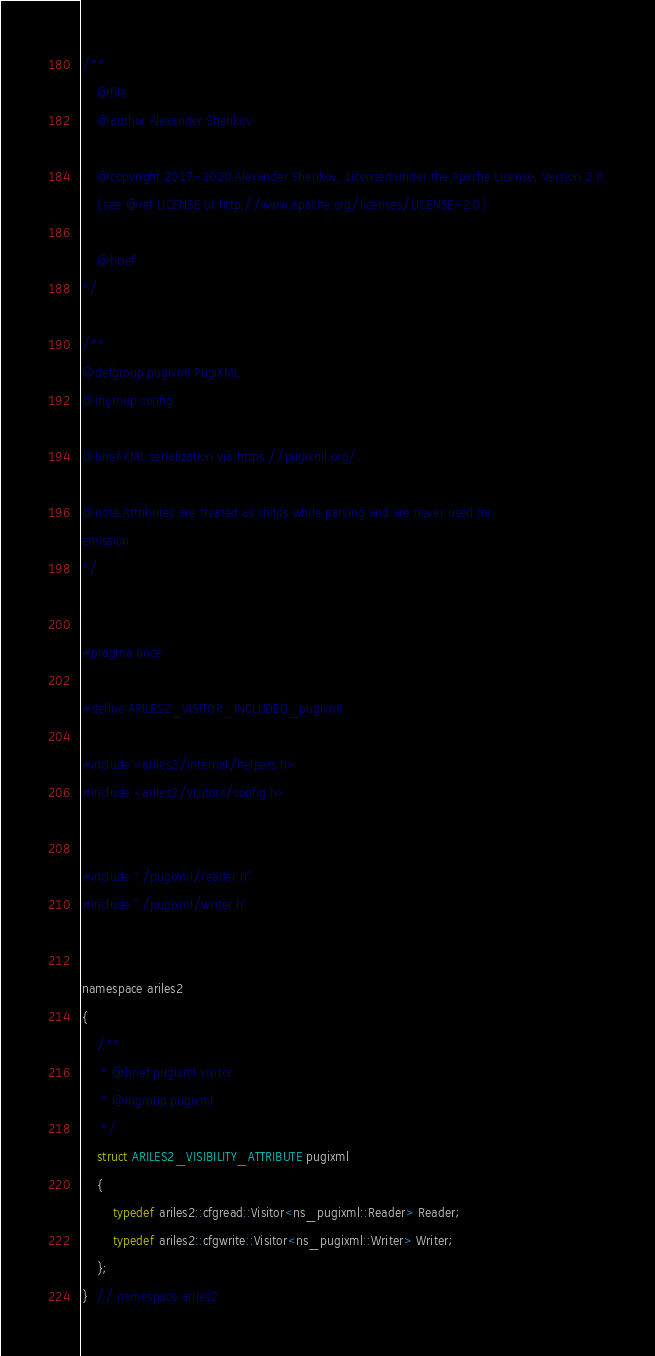<code> <loc_0><loc_0><loc_500><loc_500><_C_>/**
    @file
    @author Alexander Sherikov

    @copyright 2017-2020 Alexander Sherikov, Licensed under the Apache License, Version 2.0.
    (see @ref LICENSE or http://www.apache.org/licenses/LICENSE-2.0)

    @brief
*/

/**
@defgroup pugixml PugiXML
@ingroup config

@brief XML serialization via https://pugixml.org/.

@note Attributes are treated as childs while parsing and are never used for
emission.
*/


#pragma once

#define ARILES2_VISITOR_INCLUDED_pugixml

#include <ariles2/internal/helpers.h>
#include <ariles2/visitors/config.h>


#include "./pugixml/reader.h"
#include "./pugixml/writer.h"


namespace ariles2
{
    /**
     * @brief pugixml visitor.
     * @ingroup pugixml
     */
    struct ARILES2_VISIBILITY_ATTRIBUTE pugixml
    {
        typedef ariles2::cfgread::Visitor<ns_pugixml::Reader> Reader;
        typedef ariles2::cfgwrite::Visitor<ns_pugixml::Writer> Writer;
    };
}  // namespace ariles2
</code> 